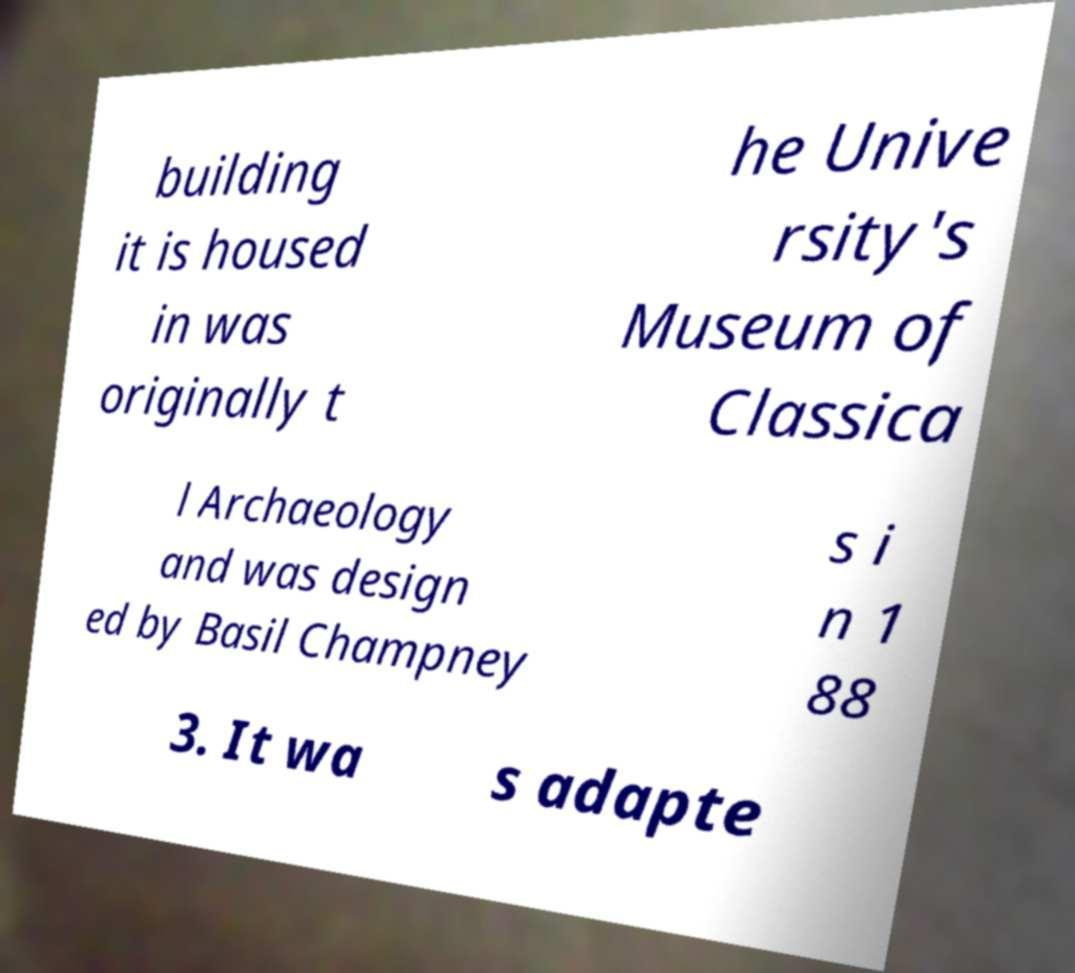For documentation purposes, I need the text within this image transcribed. Could you provide that? building it is housed in was originally t he Unive rsity's Museum of Classica l Archaeology and was design ed by Basil Champney s i n 1 88 3. It wa s adapte 